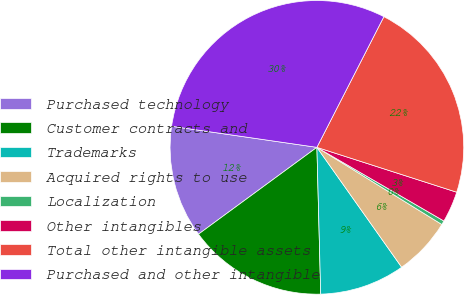Convert chart to OTSL. <chart><loc_0><loc_0><loc_500><loc_500><pie_chart><fcel>Purchased technology<fcel>Customer contracts and<fcel>Trademarks<fcel>Acquired rights to use<fcel>Localization<fcel>Other intangibles<fcel>Total other intangible assets<fcel>Purchased and other intangible<nl><fcel>12.36%<fcel>15.34%<fcel>9.38%<fcel>6.4%<fcel>0.44%<fcel>3.42%<fcel>22.4%<fcel>30.24%<nl></chart> 